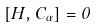Convert formula to latex. <formula><loc_0><loc_0><loc_500><loc_500>[ H , C _ { \alpha } ] = 0</formula> 